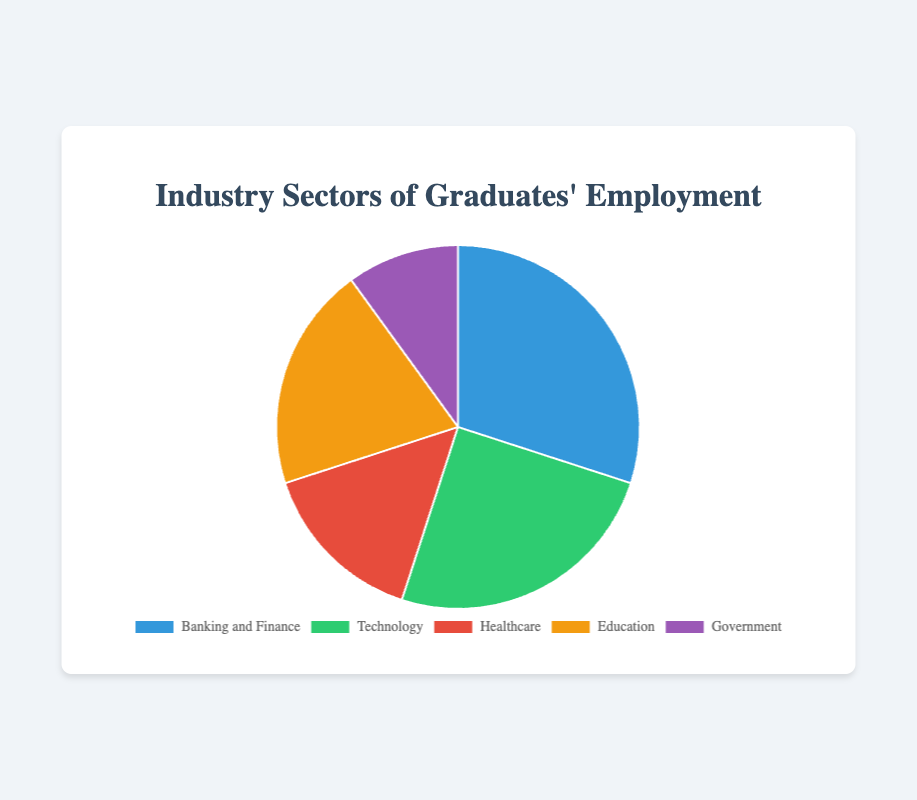Which sector has the highest percentage of graduates' employment? The sector with the highest percentage can be identified by comparing the percentages of all sectors. Banking and Finance has the highest percentage of 30%.
Answer: Banking and Finance Which sector has the lowest percentage of graduates' employment? The sector with the lowest percentage can be identified by comparing the percentages of all sectors. Government has the lowest percentage of 10%.
Answer: Government What is the combined percentage for Healthcare and Education sectors? Add the percentages for Healthcare and Education: 15% + 20% = 35%.
Answer: 35% How much higher is the employment percentage in Banking and Finance compared to Government? Subtract the percentage of Government from Banking and Finance: 30% - 10% = 20%.
Answer: 20% Which two sectors together account for half of the graduates' employment? Identify two sectors whose combined percentage equals 50%. Banking and Finance (30%) and Technology (25%) together sum up to 55%, so there are no two sectors that make exactly 50%, but Banking and Finance and Technology together make the closest to half.
Answer: Banking and Finance and Technology What is the average percentage of graduates’ employment across all sectors? Sum the percentages of all sectors and then divide by the number of sectors: (30% + 25% + 15% + 20% + 10%) / 5 = 20%.
Answer: 20% What is the difference in graduates' employment percentage between the Technology and Education sectors? Subtract the percentage of Education from Technology: 25% - 20% = 5%.
Answer: 5% Which sector has a percentage closest to the average across all sectors? The average percentage is 20%. Education has a percentage of 20%, which is closest to the average.
Answer: Education What color is used to represent the Healthcare sector in the pie chart? Observe the color assigned to the Healthcare sector; it is red in the chart.
Answer: Red If the combined percentage for Education and Healthcare is 35%, what is the combined percentage for the remaining sectors? Subtract the combined percentage of Education and Healthcare from 100%: 100% - 35% = 65%.
Answer: 65% 